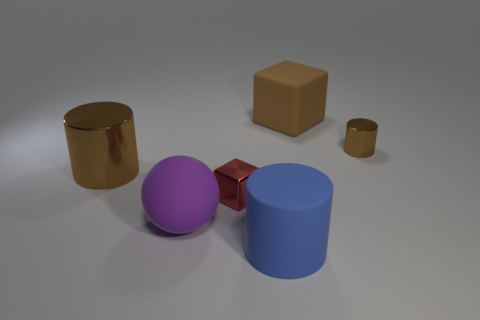Subtract all brown cylinders. How many cylinders are left? 1 Add 1 purple objects. How many objects exist? 7 Subtract all blue cylinders. How many cylinders are left? 2 Subtract all spheres. How many objects are left? 5 Subtract 2 cubes. How many cubes are left? 0 Subtract all brown cubes. Subtract all gray cylinders. How many cubes are left? 1 Subtract all blue cylinders. How many green blocks are left? 0 Subtract all tiny cylinders. Subtract all blue cylinders. How many objects are left? 4 Add 2 shiny things. How many shiny things are left? 5 Add 2 small red blocks. How many small red blocks exist? 3 